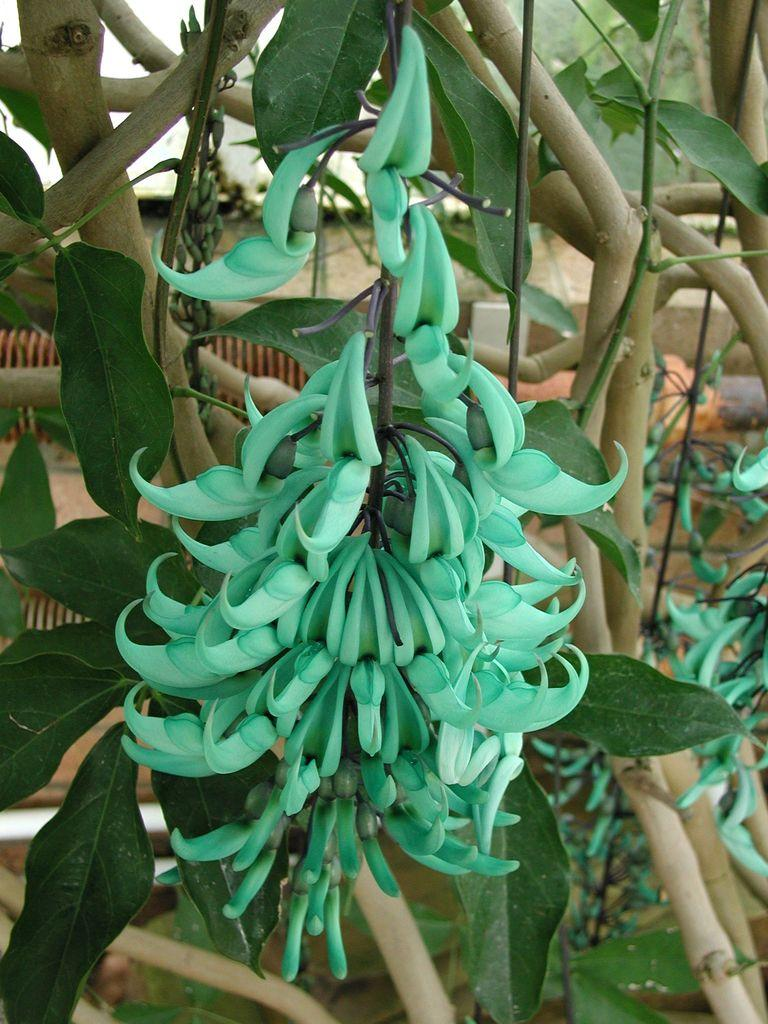What is present in the image? There is a plant in the image. What color is the plant? The plant is green in color. What features can be observed on the plant? The plant has leaves. Can you see a snail crawling on the leaves of the plant in the image? There is no snail present on the leaves of the plant in the image. What type of clover is growing alongside the plant in the image? There is no clover present alongside the plant in the image. 